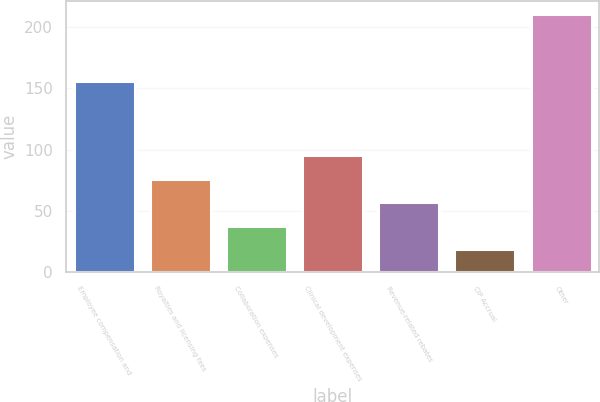Convert chart to OTSL. <chart><loc_0><loc_0><loc_500><loc_500><bar_chart><fcel>Employee compensation and<fcel>Royalties and licensing fees<fcel>Collaboration expenses<fcel>Clinical development expenses<fcel>Revenue-related rebates<fcel>CIP Accrual<fcel>Other<nl><fcel>156<fcel>76.29<fcel>37.83<fcel>95.52<fcel>57.06<fcel>18.6<fcel>210.9<nl></chart> 